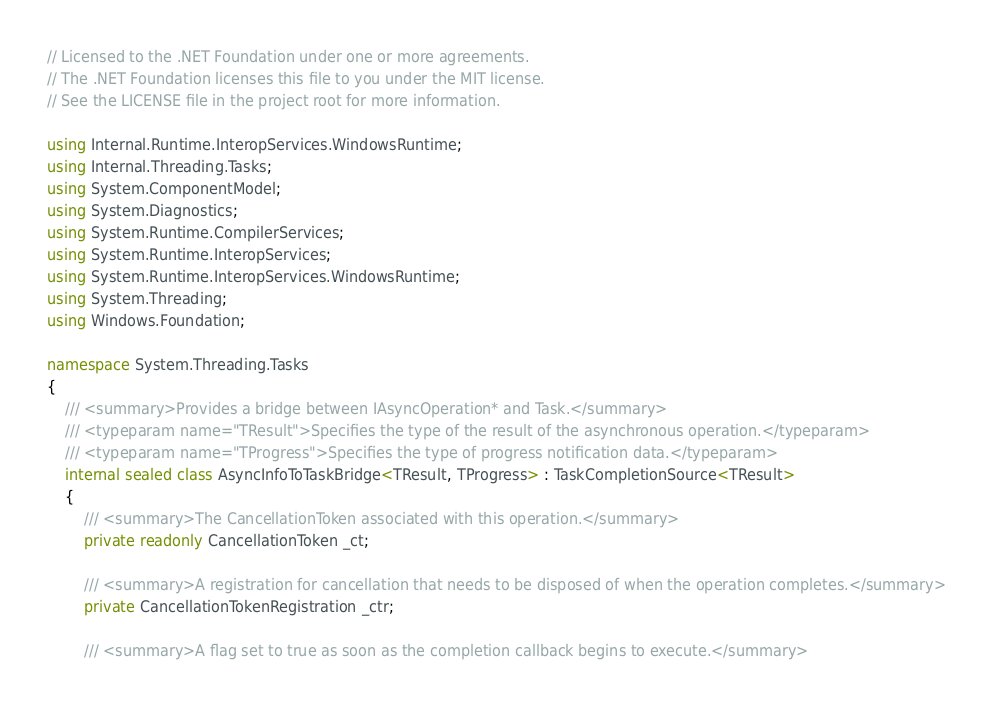Convert code to text. <code><loc_0><loc_0><loc_500><loc_500><_C#_>// Licensed to the .NET Foundation under one or more agreements.
// The .NET Foundation licenses this file to you under the MIT license.
// See the LICENSE file in the project root for more information.

using Internal.Runtime.InteropServices.WindowsRuntime;
using Internal.Threading.Tasks;
using System.ComponentModel;
using System.Diagnostics;
using System.Runtime.CompilerServices;
using System.Runtime.InteropServices;
using System.Runtime.InteropServices.WindowsRuntime;
using System.Threading;
using Windows.Foundation;

namespace System.Threading.Tasks
{
    /// <summary>Provides a bridge between IAsyncOperation* and Task.</summary>
    /// <typeparam name="TResult">Specifies the type of the result of the asynchronous operation.</typeparam>
    /// <typeparam name="TProgress">Specifies the type of progress notification data.</typeparam>
    internal sealed class AsyncInfoToTaskBridge<TResult, TProgress> : TaskCompletionSource<TResult>
    {
        /// <summary>The CancellationToken associated with this operation.</summary>
        private readonly CancellationToken _ct;

        /// <summary>A registration for cancellation that needs to be disposed of when the operation completes.</summary>
        private CancellationTokenRegistration _ctr;

        /// <summary>A flag set to true as soon as the completion callback begins to execute.</summary></code> 